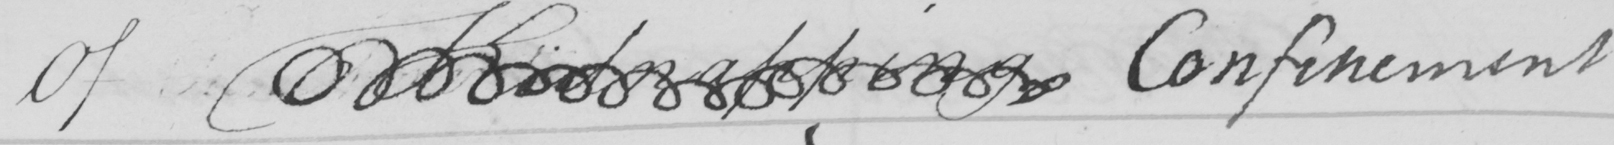Can you read and transcribe this handwriting? Of Kidnapping Confinement 